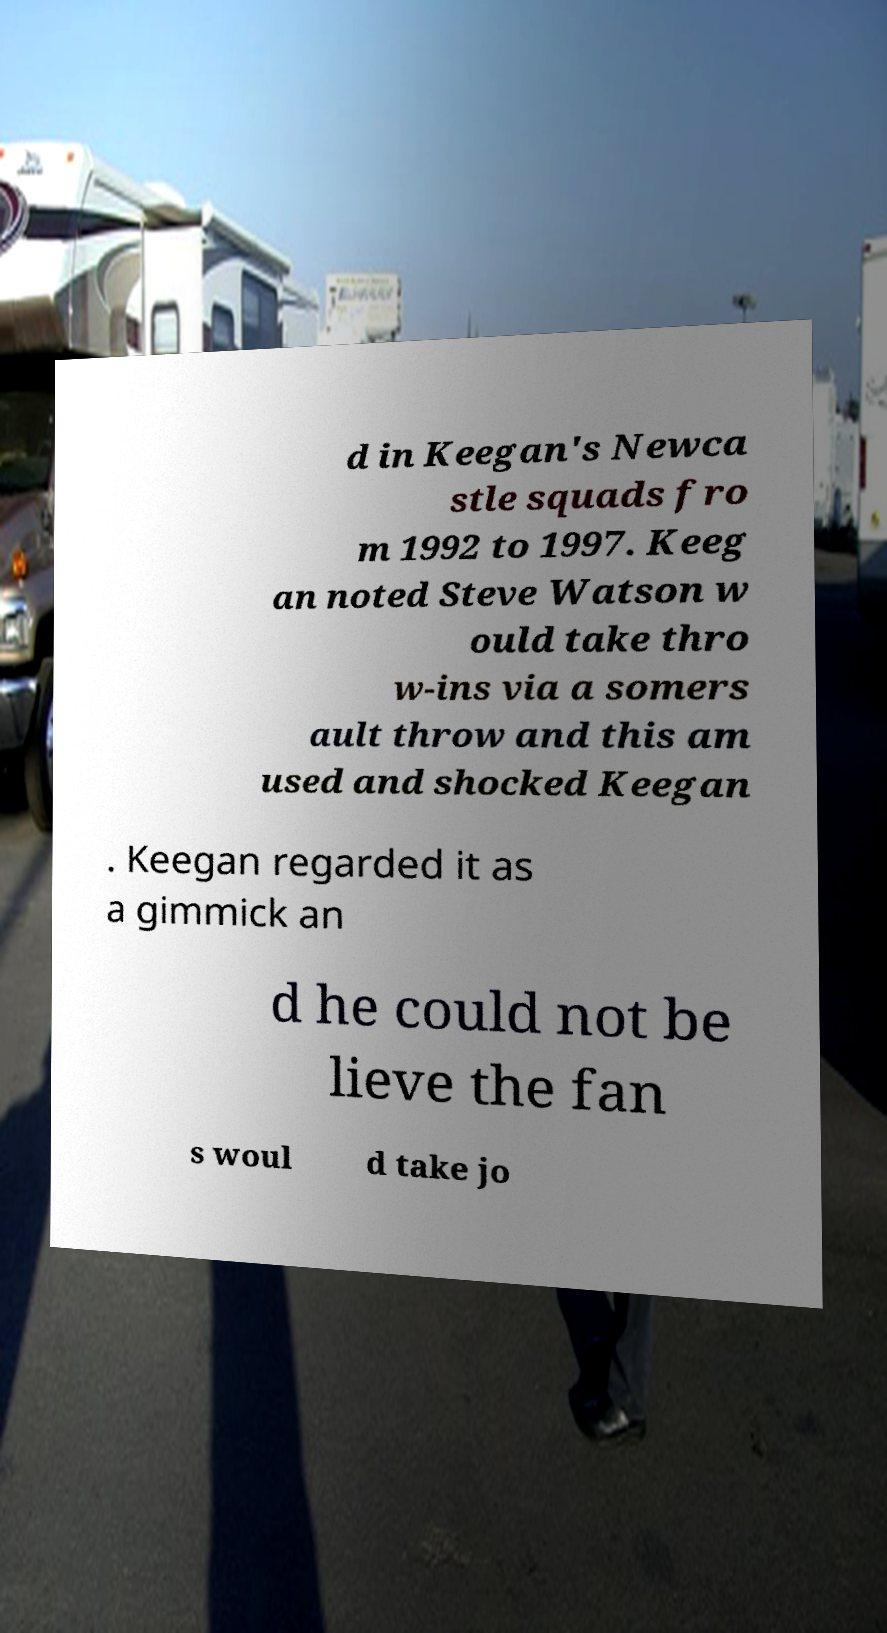There's text embedded in this image that I need extracted. Can you transcribe it verbatim? d in Keegan's Newca stle squads fro m 1992 to 1997. Keeg an noted Steve Watson w ould take thro w-ins via a somers ault throw and this am used and shocked Keegan . Keegan regarded it as a gimmick an d he could not be lieve the fan s woul d take jo 